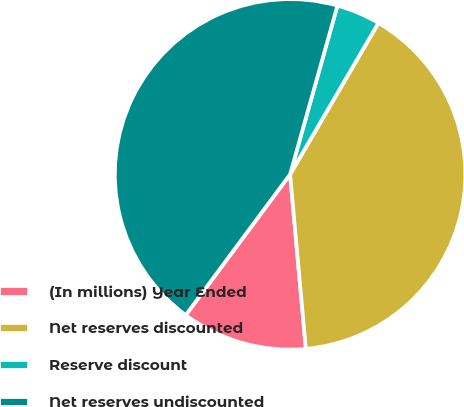Convert chart to OTSL. <chart><loc_0><loc_0><loc_500><loc_500><pie_chart><fcel>(In millions) Year Ended<fcel>Net reserves discounted<fcel>Reserve discount<fcel>Net reserves undiscounted<nl><fcel>11.59%<fcel>40.16%<fcel>4.05%<fcel>44.2%<nl></chart> 